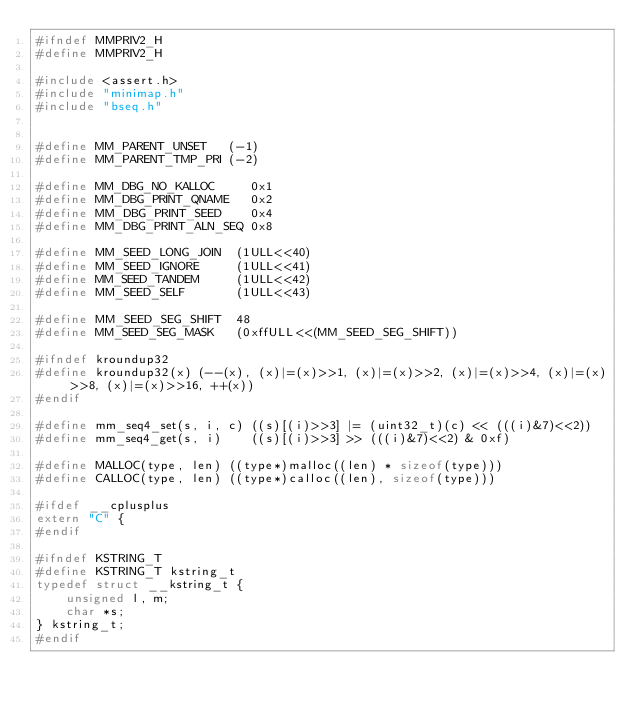<code> <loc_0><loc_0><loc_500><loc_500><_C_>#ifndef MMPRIV2_H
#define MMPRIV2_H

#include <assert.h>
#include "minimap.h"
#include "bseq.h"


#define MM_PARENT_UNSET   (-1)
#define MM_PARENT_TMP_PRI (-2)

#define MM_DBG_NO_KALLOC     0x1
#define MM_DBG_PRINT_QNAME   0x2
#define MM_DBG_PRINT_SEED    0x4
#define MM_DBG_PRINT_ALN_SEQ 0x8

#define MM_SEED_LONG_JOIN  (1ULL<<40)
#define MM_SEED_IGNORE     (1ULL<<41)
#define MM_SEED_TANDEM     (1ULL<<42)
#define MM_SEED_SELF       (1ULL<<43)

#define MM_SEED_SEG_SHIFT  48
#define MM_SEED_SEG_MASK   (0xffULL<<(MM_SEED_SEG_SHIFT))

#ifndef kroundup32
#define kroundup32(x) (--(x), (x)|=(x)>>1, (x)|=(x)>>2, (x)|=(x)>>4, (x)|=(x)>>8, (x)|=(x)>>16, ++(x))
#endif

#define mm_seq4_set(s, i, c) ((s)[(i)>>3] |= (uint32_t)(c) << (((i)&7)<<2))
#define mm_seq4_get(s, i)    ((s)[(i)>>3] >> (((i)&7)<<2) & 0xf)

#define MALLOC(type, len) ((type*)malloc((len) * sizeof(type)))
#define CALLOC(type, len) ((type*)calloc((len), sizeof(type)))

#ifdef __cplusplus
extern "C" {
#endif

#ifndef KSTRING_T
#define KSTRING_T kstring_t
typedef struct __kstring_t {
	unsigned l, m;
	char *s;
} kstring_t;
#endif
</code> 